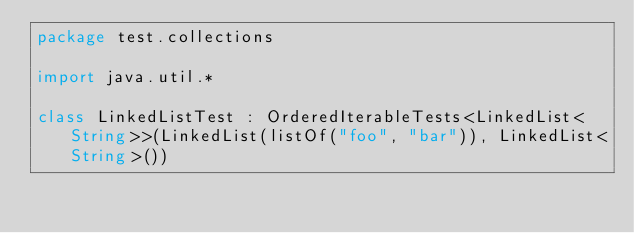Convert code to text. <code><loc_0><loc_0><loc_500><loc_500><_Kotlin_>package test.collections

import java.util.*

class LinkedListTest : OrderedIterableTests<LinkedList<String>>(LinkedList(listOf("foo", "bar")), LinkedList<String>())

</code> 